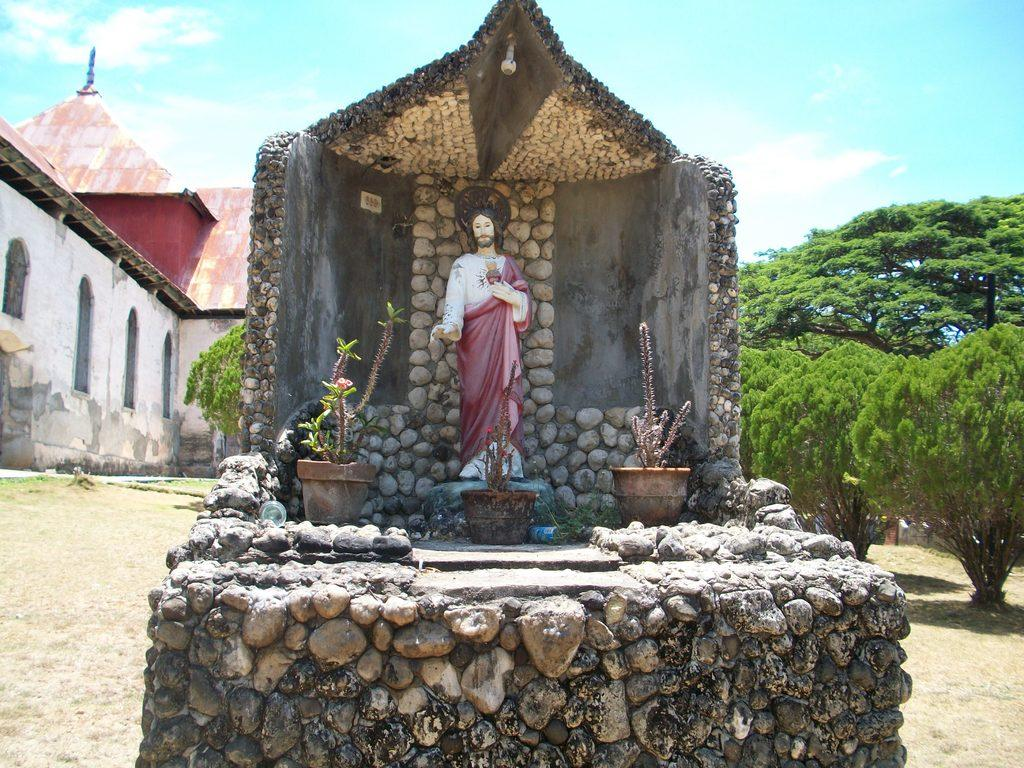What is the main subject of the image? There is a sculpture on stone in the image. What other objects or elements can be seen in the image? There are house plants in the image. What can be seen in the background of the image? There is a building and trees in the background of the image, as well as the sky. What type of cap is the sculpture wearing in the image? There is no cap present on the sculpture in the image. What idea does the sculpture represent in the image? The image does not provide any information about the meaning or idea represented by the sculpture. 